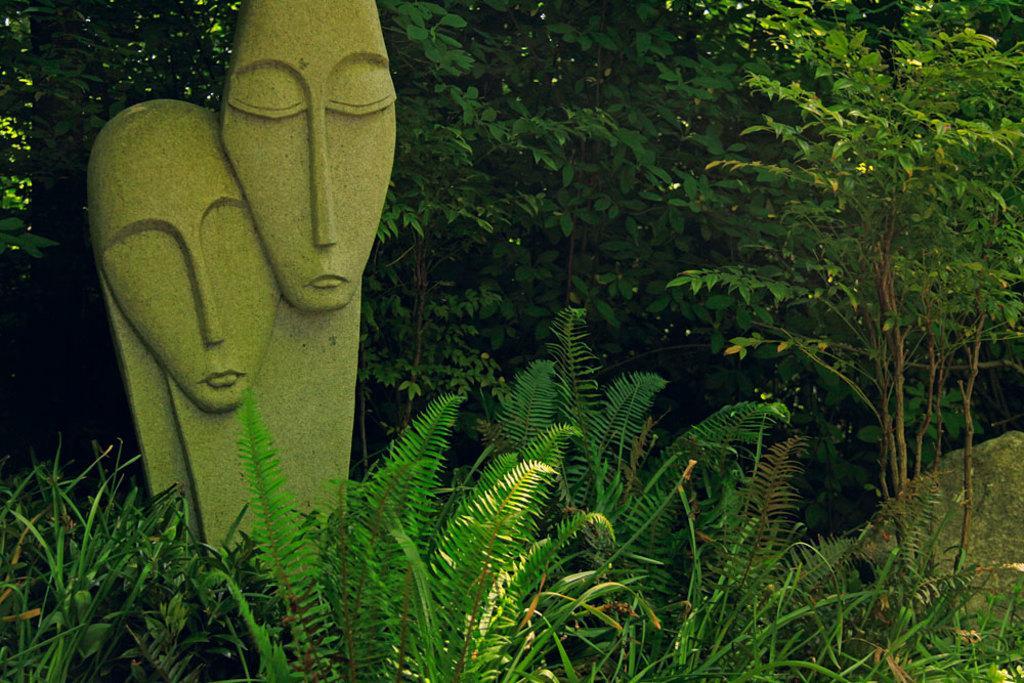Can you describe this image briefly? In this image I can see two statues in green color, background I can see plants and trees in green color. 